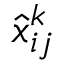Convert formula to latex. <formula><loc_0><loc_0><loc_500><loc_500>\hat { x } _ { i j } ^ { k }</formula> 